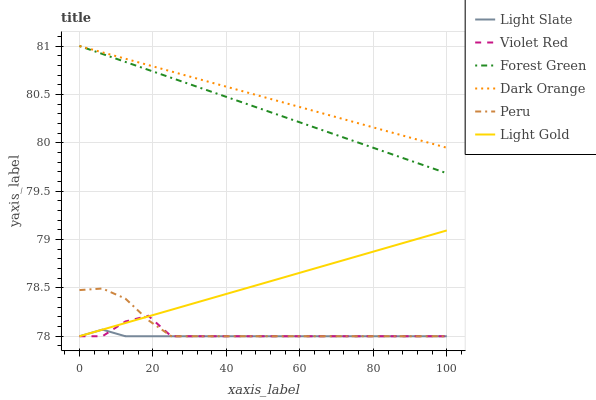Does Violet Red have the minimum area under the curve?
Answer yes or no. No. Does Violet Red have the maximum area under the curve?
Answer yes or no. No. Is Light Slate the smoothest?
Answer yes or no. No. Is Light Slate the roughest?
Answer yes or no. No. Does Forest Green have the lowest value?
Answer yes or no. No. Does Violet Red have the highest value?
Answer yes or no. No. Is Peru less than Forest Green?
Answer yes or no. Yes. Is Dark Orange greater than Light Slate?
Answer yes or no. Yes. Does Peru intersect Forest Green?
Answer yes or no. No. 